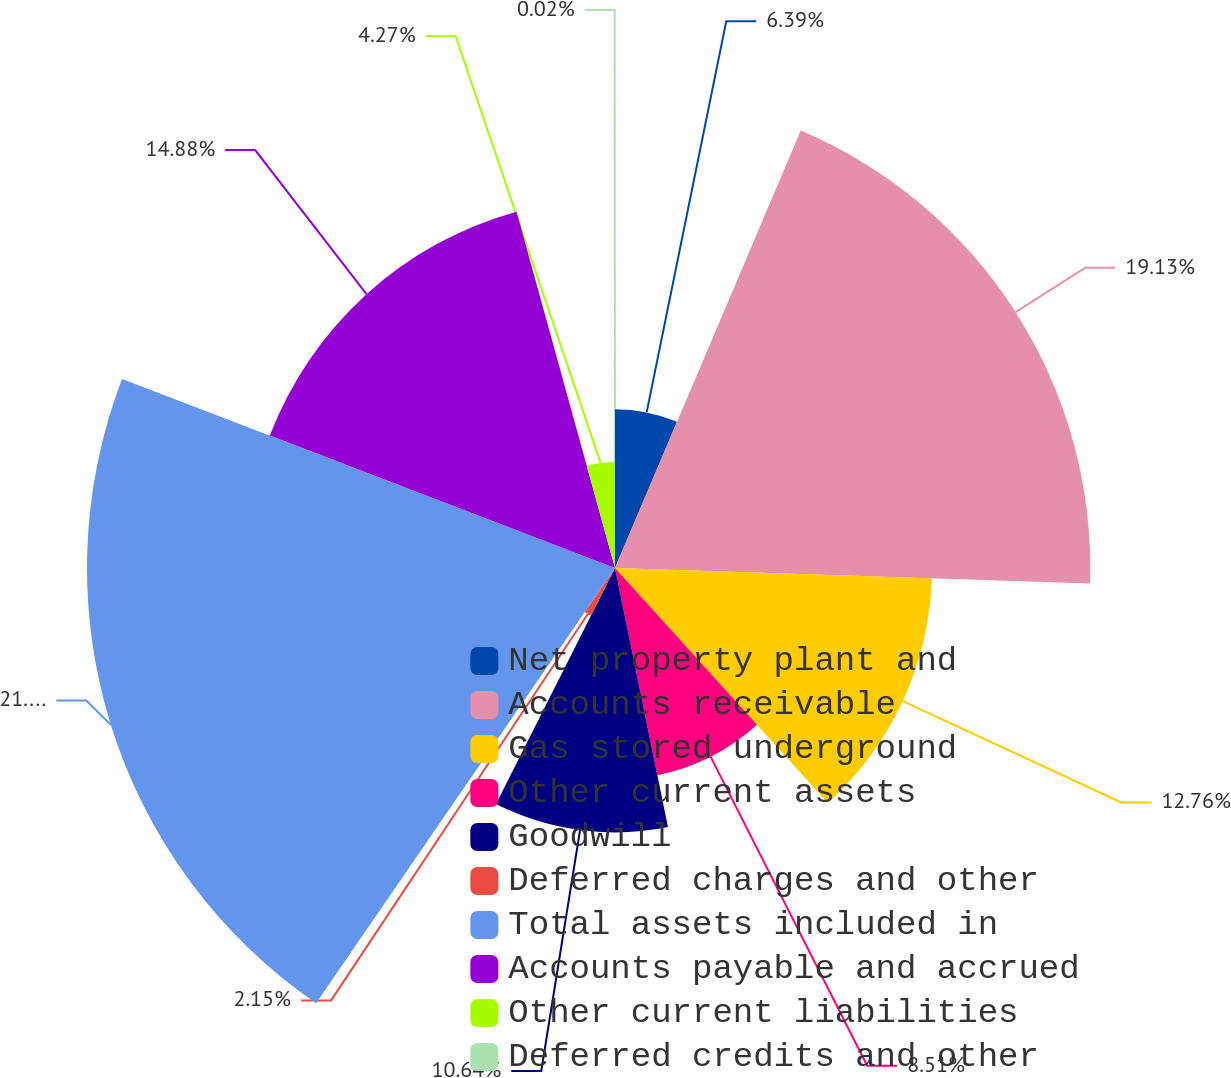<chart> <loc_0><loc_0><loc_500><loc_500><pie_chart><fcel>Net property plant and<fcel>Accounts receivable<fcel>Gas stored underground<fcel>Other current assets<fcel>Goodwill<fcel>Deferred charges and other<fcel>Total assets included in<fcel>Accounts payable and accrued<fcel>Other current liabilities<fcel>Deferred credits and other<nl><fcel>6.39%<fcel>19.13%<fcel>12.76%<fcel>8.51%<fcel>10.64%<fcel>2.15%<fcel>21.25%<fcel>14.88%<fcel>4.27%<fcel>0.02%<nl></chart> 